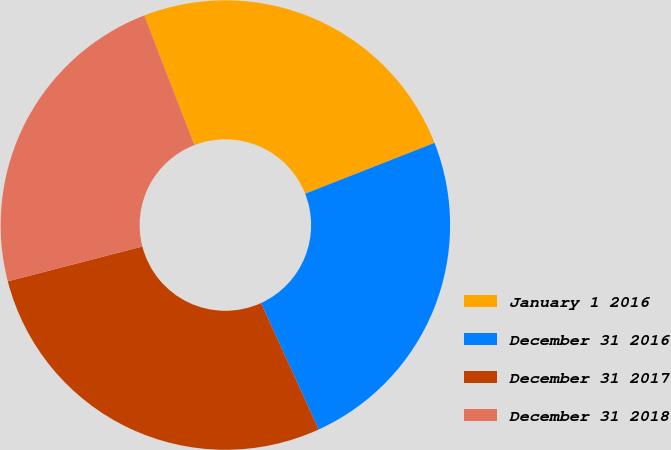Convert chart. <chart><loc_0><loc_0><loc_500><loc_500><pie_chart><fcel>January 1 2016<fcel>December 31 2016<fcel>December 31 2017<fcel>December 31 2018<nl><fcel>24.92%<fcel>24.14%<fcel>27.79%<fcel>23.15%<nl></chart> 